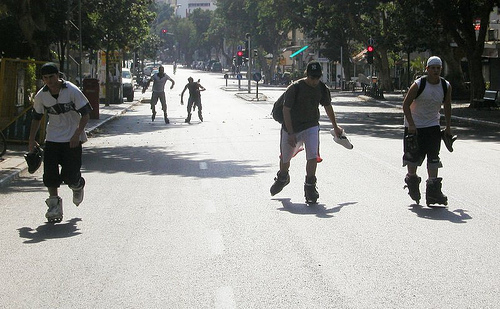What safety equipment should individuals wear while rollerblading in settings like this? For optimal safety while rollerblading, individuals should wear a helmet to protect the head during falls. Additionally, knee pads, elbow pads, and wrist guards are recommended to prevent scrapes and fractures. Padded shorts can also provide protection for the hips and tailbone. 